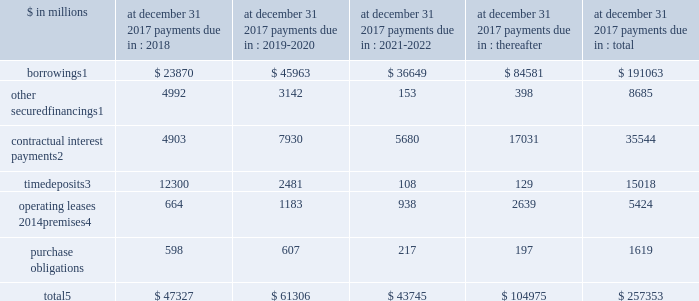Management 2019s discussion and analysis expected replacement of london interbank offered rate central banks around the world , including the federal reserve , have commissioned working groups of market participants and others with the goal of finding suitable replacements for libor based on observable market transac- tions .
It is expected that a transition away from the wide- spread use of libor to alternative rates will occur over the course of the next few years .
Effects of inflation and changes in interest and foreign exchange rates to the extent that an increased inflation outlook results in rising interest rates or has negative impacts on the valuation of financial instruments that exceed the impact on the value of our liabilities , it may adversely affect our financial position and profitability .
Rising inflation may also result in increases in our non-interest expenses that may not be readily recover- able in higher prices of services offered .
Other changes in the interest rate environment and related volatility , as well as expectations about the level of future interest rates , could also impact our results of operations .
A significant portion of our business is conducted in curren- cies other than the u.s .
Dollar , and changes in foreign exchange rates relative to the u.s .
Dollar , therefore , can affect the value of non-u.s .
Dollar net assets , revenues and expenses .
Potential exposures as a result of these fluctuations in currencies are closely monitored , and , where cost-justified , strategies are adopted that are designed to reduce the impact of these fluctuations on our financial performance .
These strategies may include the financing of non-u.s .
Dollar assets with direct or swap-based borrowings in the same currency and the use of currency forward contracts or the spot market in various hedging transactions related to net assets , revenues , expenses or cash flows .
For information about cumulative foreign currency translation adjustments , see note 15 to the financial statements .
Off-balance sheet arrangements and contractual obligations off-balance sheet arrangements we enter into various off-balance sheet arrangements , including through unconsolidated spes and lending-related financial instruments ( e.g. , guarantees and commitments ) , primarily in connection with the institutional securities and investment management business segments .
We utilize spes primarily in connection with securitization activities .
For information on our securitization activities , see note 13 to the financial statements .
For information on our commitments , obligations under certain guarantee arrangements and indemnities , see note 12 to the financial statements .
For further information on our lending commitments , see 201cquantitative and qualitative disclosures about market risk 2014risk management 2014credit risk 2014lending activities . 201d contractual obligations in the normal course of business , we enter into various contractual obligations that may require future cash payments .
Contractual obligations include certain borrow- ings , other secured financings , contractual interest payments , contractual payments on time deposits , operating leases and purchase obligations .
Contractual obligations at december 31 , 2017 payments due in : $ in millions 2018 2019-2020 2021-2022 thereafter total borrowings1 $ 23870 $ 45963 $ 36649 $ 84581 $ 191063 other secured financings1 4992 3142 153 398 8685 contractual interest payments2 4903 7930 5680 17031 35544 time deposits3 12300 2481 108 129 15018 operating leases 2014premises4 664 1183 938 2639 5424 purchase obligations 598 607 217 197 1619 total5 $ 47327 $ 61306 $ 43745 $ 104975 $ 257353 1 .
For further information on borrowings and other secured financings , see note 11 to the financial statements .
Amounts presented for borrowings and other secured financings are financings with original maturities greater than one year .
Amounts represent estimated future contractual interest payments related to unse- cured borrowings with original maturities greater than one year based on applicable interest rates at december 31 , 2017 .
Amounts represent contractual principal and interest payments related to time deposits primarily held at our u.s .
Bank subsidiaries .
For further information on operating leases covering premises and equipment , see note 12 to the financial statements .
Amounts exclude unrecognized tax benefits , as the timing and amount of future cash payments are not determinable at this time ( see note 20 to the financial state- ments for further information ) .
Purchase obligations for goods and services include payments for , among other things , consulting , outsourcing , computer and telecommunications maintenance agreements , and certain transmission , transportation and storage contracts related to the commodities business .
Purchase obligations at december 31 , 2017 reflect the minimum contractual obliga- tion under legally enforceable contracts with contract terms that are both fixed and determinable .
These amounts exclude obligations for goods and services that already have been incurred and are reflected in the balance sheets .
December 2017 form 10-k 70 .
Management 2019s discussion and analysis expected replacement of london interbank offered rate central banks around the world , including the federal reserve , have commissioned working groups of market participants and others with the goal of finding suitable replacements for libor based on observable market transac- tions .
It is expected that a transition away from the wide- spread use of libor to alternative rates will occur over the course of the next few years .
Effects of inflation and changes in interest and foreign exchange rates to the extent that an increased inflation outlook results in rising interest rates or has negative impacts on the valuation of financial instruments that exceed the impact on the value of our liabilities , it may adversely affect our financial position and profitability .
Rising inflation may also result in increases in our non-interest expenses that may not be readily recover- able in higher prices of services offered .
Other changes in the interest rate environment and related volatility , as well as expectations about the level of future interest rates , could also impact our results of operations .
A significant portion of our business is conducted in curren- cies other than the u.s .
Dollar , and changes in foreign exchange rates relative to the u.s .
Dollar , therefore , can affect the value of non-u.s .
Dollar net assets , revenues and expenses .
Potential exposures as a result of these fluctuations in currencies are closely monitored , and , where cost-justified , strategies are adopted that are designed to reduce the impact of these fluctuations on our financial performance .
These strategies may include the financing of non-u.s .
Dollar assets with direct or swap-based borrowings in the same currency and the use of currency forward contracts or the spot market in various hedging transactions related to net assets , revenues , expenses or cash flows .
For information about cumulative foreign currency translation adjustments , see note 15 to the financial statements .
Off-balance sheet arrangements and contractual obligations off-balance sheet arrangements we enter into various off-balance sheet arrangements , including through unconsolidated spes and lending-related financial instruments ( e.g. , guarantees and commitments ) , primarily in connection with the institutional securities and investment management business segments .
We utilize spes primarily in connection with securitization activities .
For information on our securitization activities , see note 13 to the financial statements .
For information on our commitments , obligations under certain guarantee arrangements and indemnities , see note 12 to the financial statements .
For further information on our lending commitments , see 201cquantitative and qualitative disclosures about market risk 2014risk management 2014credit risk 2014lending activities . 201d contractual obligations in the normal course of business , we enter into various contractual obligations that may require future cash payments .
Contractual obligations include certain borrow- ings , other secured financings , contractual interest payments , contractual payments on time deposits , operating leases and purchase obligations .
Contractual obligations at december 31 , 2017 payments due in : $ in millions 2018 2019-2020 2021-2022 thereafter total borrowings1 $ 23870 $ 45963 $ 36649 $ 84581 $ 191063 other secured financings1 4992 3142 153 398 8685 contractual interest payments2 4903 7930 5680 17031 35544 time deposits3 12300 2481 108 129 15018 operating leases 2014premises4 664 1183 938 2639 5424 purchase obligations 598 607 217 197 1619 total5 $ 47327 $ 61306 $ 43745 $ 104975 $ 257353 1 .
For further information on borrowings and other secured financings , see note 11 to the financial statements .
Amounts presented for borrowings and other secured financings are financings with original maturities greater than one year .
Amounts represent estimated future contractual interest payments related to unse- cured borrowings with original maturities greater than one year based on applicable interest rates at december 31 , 2017 .
Amounts represent contractual principal and interest payments related to time deposits primarily held at our u.s .
Bank subsidiaries .
For further information on operating leases covering premises and equipment , see note 12 to the financial statements .
Amounts exclude unrecognized tax benefits , as the timing and amount of future cash payments are not determinable at this time ( see note 20 to the financial state- ments for further information ) .
Purchase obligations for goods and services include payments for , among other things , consulting , outsourcing , computer and telecommunications maintenance agreements , and certain transmission , transportation and storage contracts related to the commodities business .
Purchase obligations at december 31 , 2017 reflect the minimum contractual obliga- tion under legally enforceable contracts with contract terms that are both fixed and determinable .
These amounts exclude obligations for goods and services that already have been incurred and are reflected in the balance sheets .
December 2017 form 10-k 70 .
What percentage of total payments due in 2019-2020 are time deposits? 
Computations: (2481 / 61306)
Answer: 0.04047. 